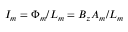Convert formula to latex. <formula><loc_0><loc_0><loc_500><loc_500>I _ { m } = \Phi _ { m } / L _ { m } = B _ { z } A _ { m } / L _ { m }</formula> 